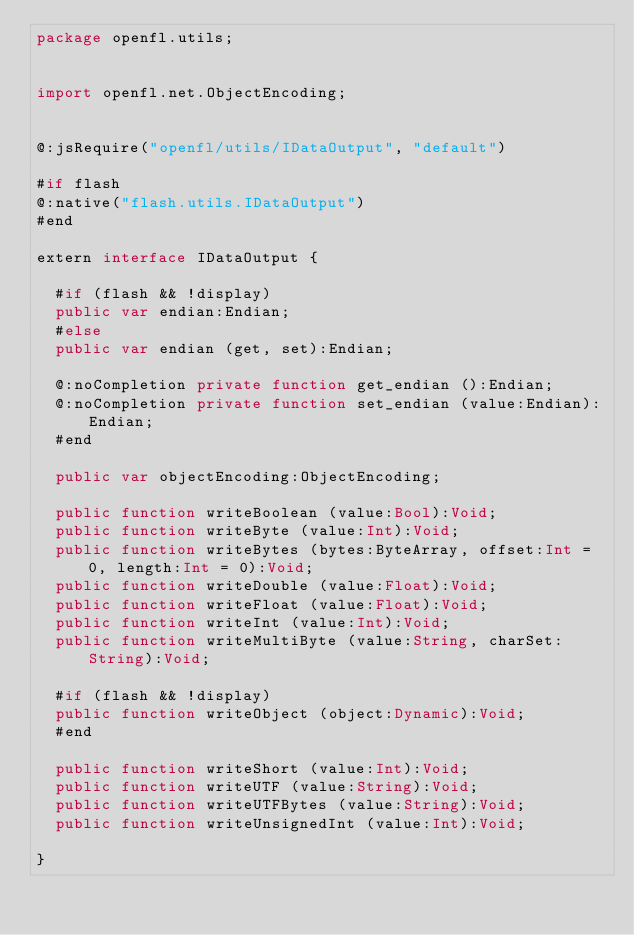<code> <loc_0><loc_0><loc_500><loc_500><_Haxe_>package openfl.utils;


import openfl.net.ObjectEncoding;


@:jsRequire("openfl/utils/IDataOutput", "default")

#if flash
@:native("flash.utils.IDataOutput")
#end

extern interface IDataOutput {
	
	#if (flash && !display)
	public var endian:Endian;
	#else
	public var endian (get, set):Endian;
	
	@:noCompletion private function get_endian ():Endian;
	@:noCompletion private function set_endian (value:Endian):Endian;
	#end
	
	public var objectEncoding:ObjectEncoding;
	
	public function writeBoolean (value:Bool):Void;
	public function writeByte (value:Int):Void;
	public function writeBytes (bytes:ByteArray, offset:Int = 0, length:Int = 0):Void;
	public function writeDouble (value:Float):Void;
	public function writeFloat (value:Float):Void;
	public function writeInt (value:Int):Void;
	public function writeMultiByte (value:String, charSet:String):Void;
	
	#if (flash && !display)
	public function writeObject (object:Dynamic):Void;
	#end
	
	public function writeShort (value:Int):Void;
	public function writeUTF (value:String):Void;
	public function writeUTFBytes (value:String):Void;
	public function writeUnsignedInt (value:Int):Void;
	
}
</code> 